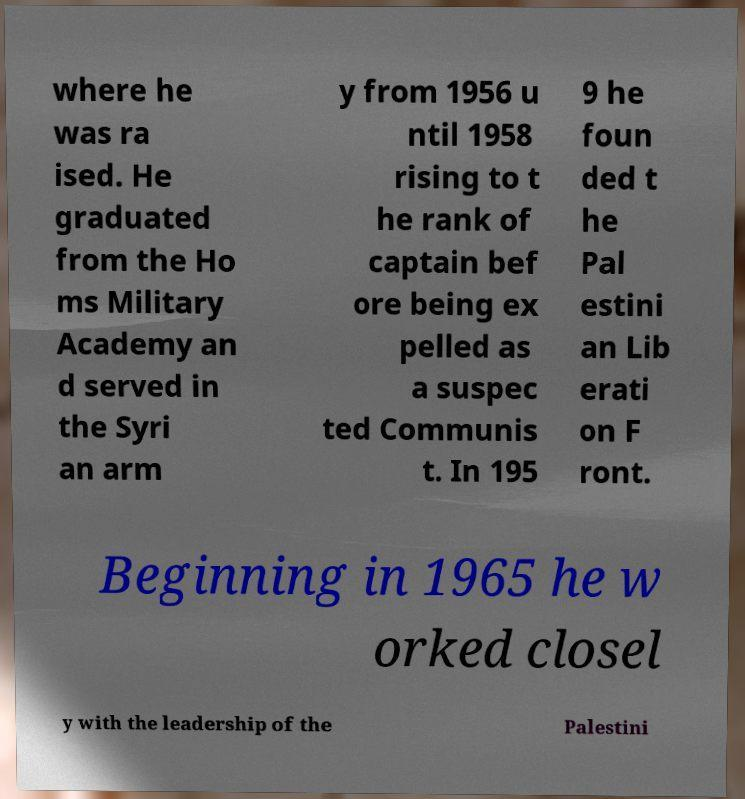There's text embedded in this image that I need extracted. Can you transcribe it verbatim? where he was ra ised. He graduated from the Ho ms Military Academy an d served in the Syri an arm y from 1956 u ntil 1958 rising to t he rank of captain bef ore being ex pelled as a suspec ted Communis t. In 195 9 he foun ded t he Pal estini an Lib erati on F ront. Beginning in 1965 he w orked closel y with the leadership of the Palestini 